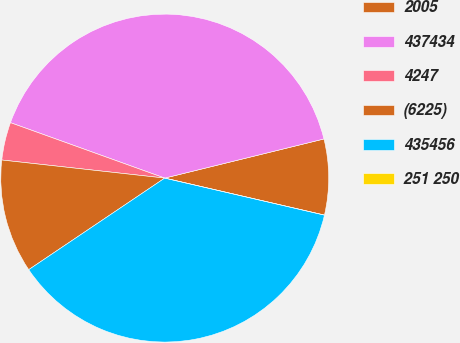Convert chart to OTSL. <chart><loc_0><loc_0><loc_500><loc_500><pie_chart><fcel>2005<fcel>437434<fcel>4247<fcel>(6225)<fcel>435456<fcel>251 250<nl><fcel>7.46%<fcel>40.67%<fcel>3.73%<fcel>11.19%<fcel>36.94%<fcel>0.0%<nl></chart> 